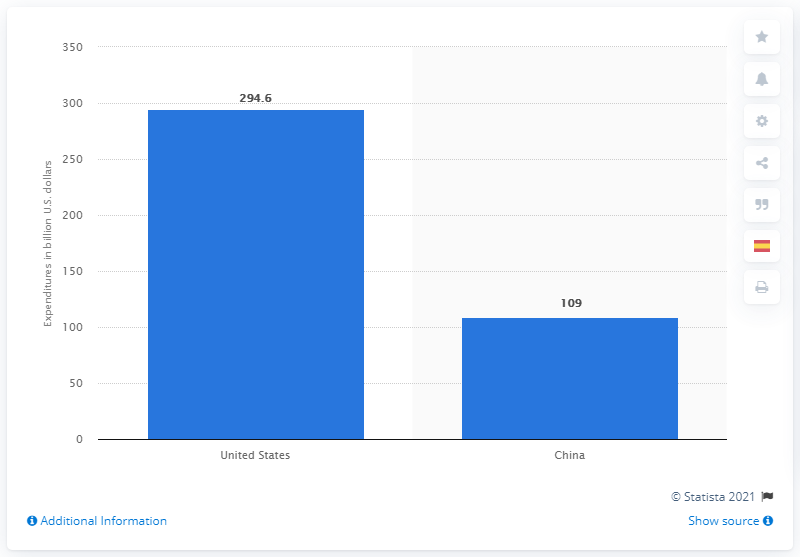Draw attention to some important aspects in this diagram. In 2019, the United States spent approximately $294.6 billion on treating diabetes. In 2019, China spent $109 billion on treating diabetes. 